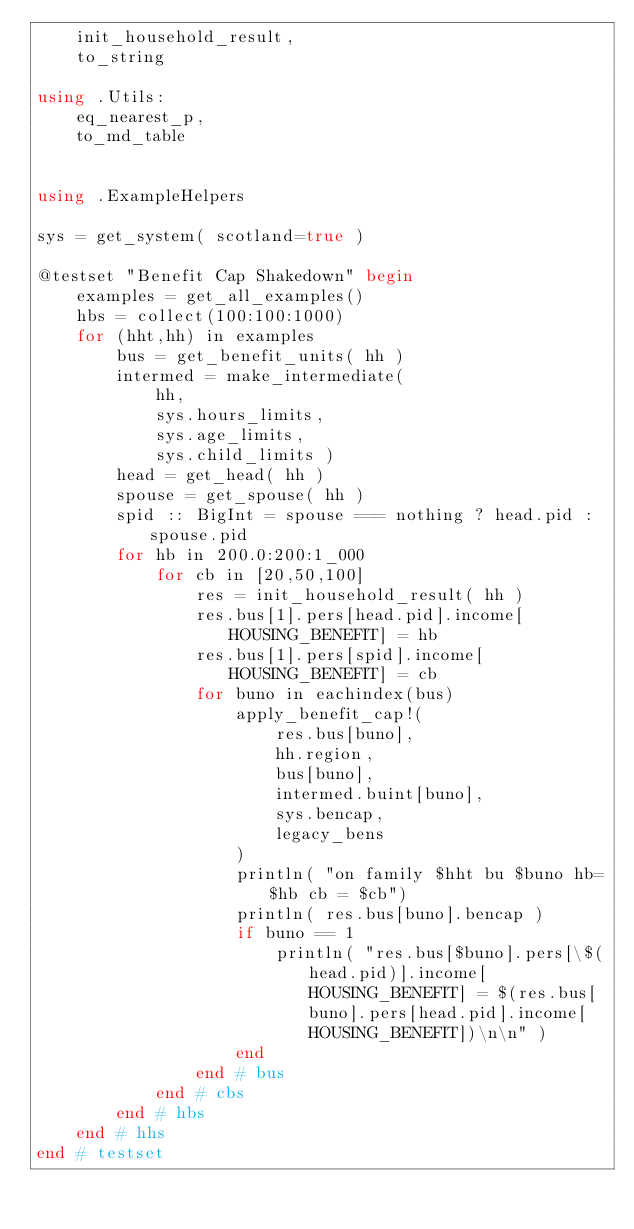Convert code to text. <code><loc_0><loc_0><loc_500><loc_500><_Julia_>    init_household_result, 
    to_string

using .Utils: 
    eq_nearest_p,
    to_md_table


using .ExampleHelpers

sys = get_system( scotland=true )

@testset "Benefit Cap Shakedown" begin
    examples = get_all_examples()
    hbs = collect(100:100:1000)
    for (hht,hh) in examples 
        bus = get_benefit_units( hh )
        intermed = make_intermediate( 
            hh,
            sys.hours_limits,
            sys.age_limits,
            sys.child_limits )
        head = get_head( hh )
        spouse = get_spouse( hh )
        spid :: BigInt = spouse === nothing ? head.pid : spouse.pid
        for hb in 200.0:200:1_000
            for cb in [20,50,100]
                res = init_household_result( hh )
                res.bus[1].pers[head.pid].income[HOUSING_BENEFIT] = hb
                res.bus[1].pers[spid].income[HOUSING_BENEFIT] = cb
                for buno in eachindex(bus) 
                    apply_benefit_cap!(
                        res.bus[buno],
                        hh.region,
                        bus[buno],
                        intermed.buint[buno],
                        sys.bencap,
                        legacy_bens
                    )
                    println( "on family $hht bu $buno hb=$hb cb = $cb")
                    println( res.bus[buno].bencap )
                    if buno == 1
                        println( "res.bus[$buno].pers[\$(head.pid)].income[HOUSING_BENEFIT] = $(res.bus[buno].pers[head.pid].income[HOUSING_BENEFIT])\n\n" ) 
                    end
                end # bus
            end # cbs
        end # hbs
    end # hhs
end # testset</code> 